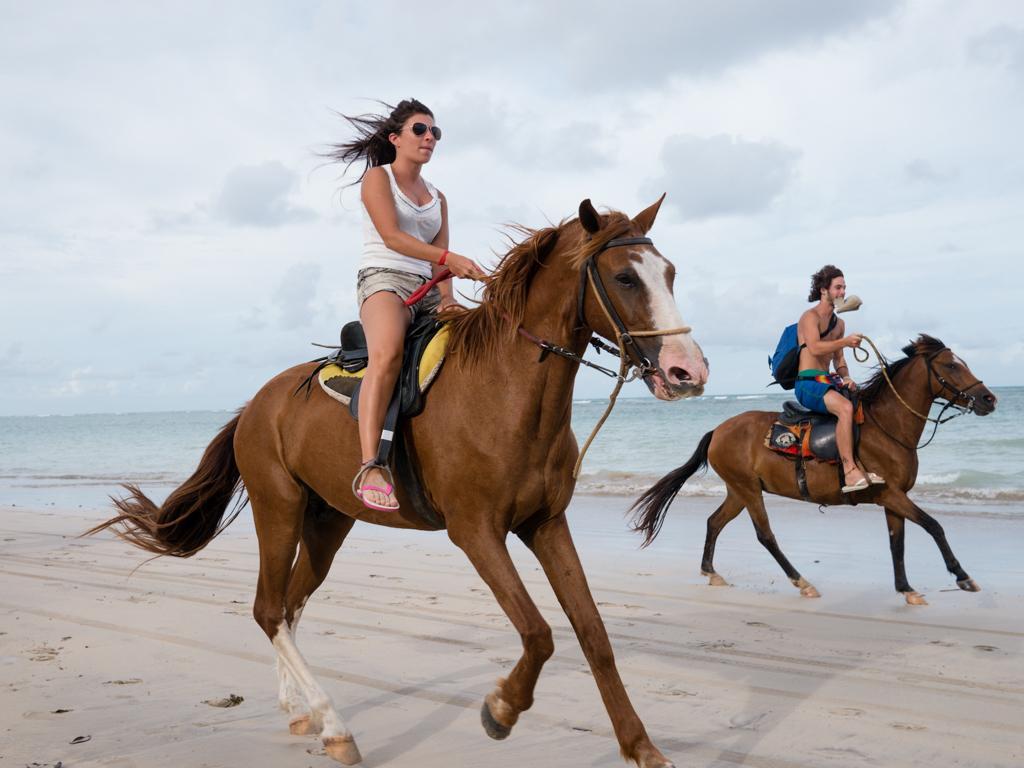Who is present in the image? There is a woman and a man in the image. What are the woman and man doing in the image? Both the woman and man are riding a horse in the image. Where does the scene take place? The scene takes place at the beach. What is the condition of the sky in the image? The sky is full of clouds in the image. What is the ground made of in the image? The ground is not visible in the image, as the scene takes place on a horse. What sense is being stimulated by the clouds in the image? The clouds in the image do not stimulate any specific sense; they are simply a part of the sky's appearance. 